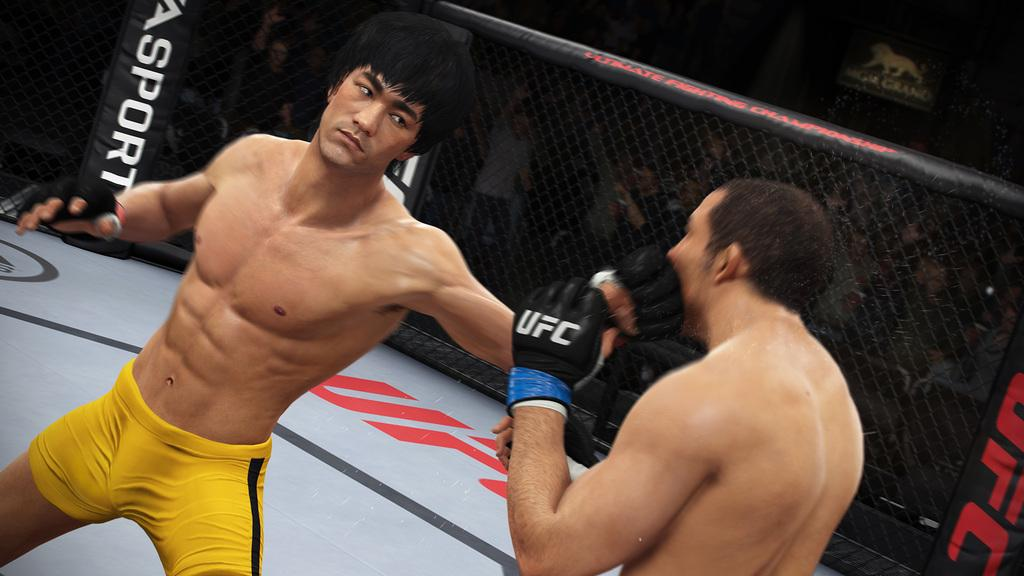<image>
Present a compact description of the photo's key features. Two UFC fighters in a ring with an ad for ASport 